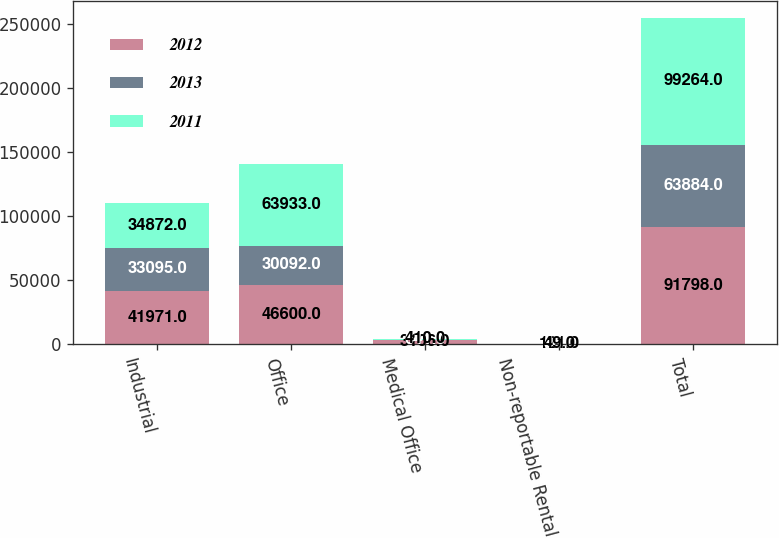<chart> <loc_0><loc_0><loc_500><loc_500><stacked_bar_chart><ecel><fcel>Industrial<fcel>Office<fcel>Medical Office<fcel>Non-reportable Rental<fcel>Total<nl><fcel>2012<fcel>41971<fcel>46600<fcel>3106<fcel>121<fcel>91798<nl><fcel>2013<fcel>33095<fcel>30092<fcel>641<fcel>56<fcel>63884<nl><fcel>2011<fcel>34872<fcel>63933<fcel>410<fcel>49<fcel>99264<nl></chart> 